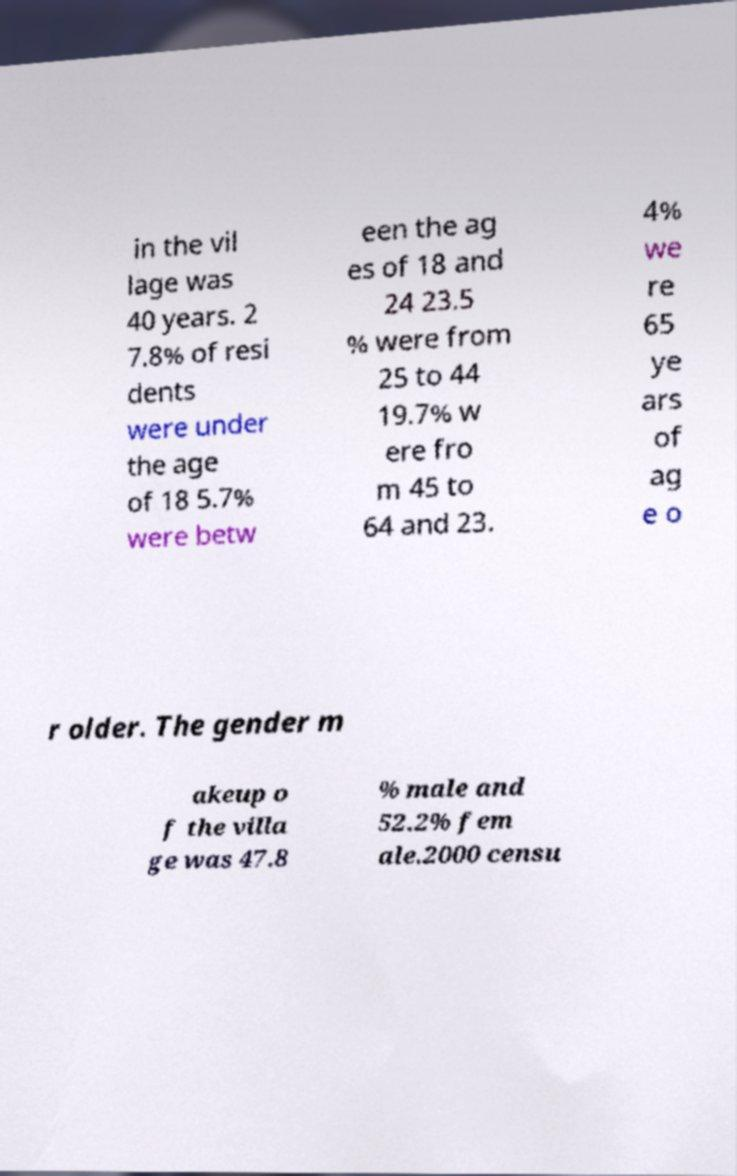I need the written content from this picture converted into text. Can you do that? in the vil lage was 40 years. 2 7.8% of resi dents were under the age of 18 5.7% were betw een the ag es of 18 and 24 23.5 % were from 25 to 44 19.7% w ere fro m 45 to 64 and 23. 4% we re 65 ye ars of ag e o r older. The gender m akeup o f the villa ge was 47.8 % male and 52.2% fem ale.2000 censu 